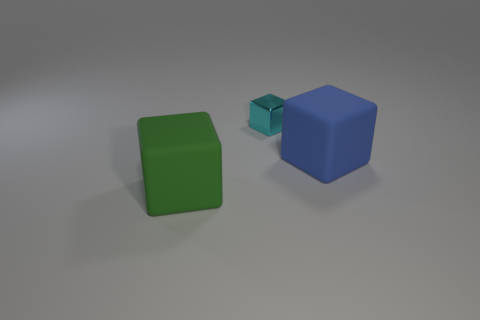Add 1 big cyan rubber spheres. How many objects exist? 4 Subtract all big blocks. How many blocks are left? 1 Subtract 1 cubes. How many cubes are left? 2 Subtract all blue cubes. How many cubes are left? 2 Subtract all brown cubes. Subtract all purple cylinders. How many cubes are left? 3 Subtract all purple matte cylinders. Subtract all blocks. How many objects are left? 0 Add 3 blocks. How many blocks are left? 6 Add 2 tiny yellow matte things. How many tiny yellow matte things exist? 2 Subtract 0 brown blocks. How many objects are left? 3 